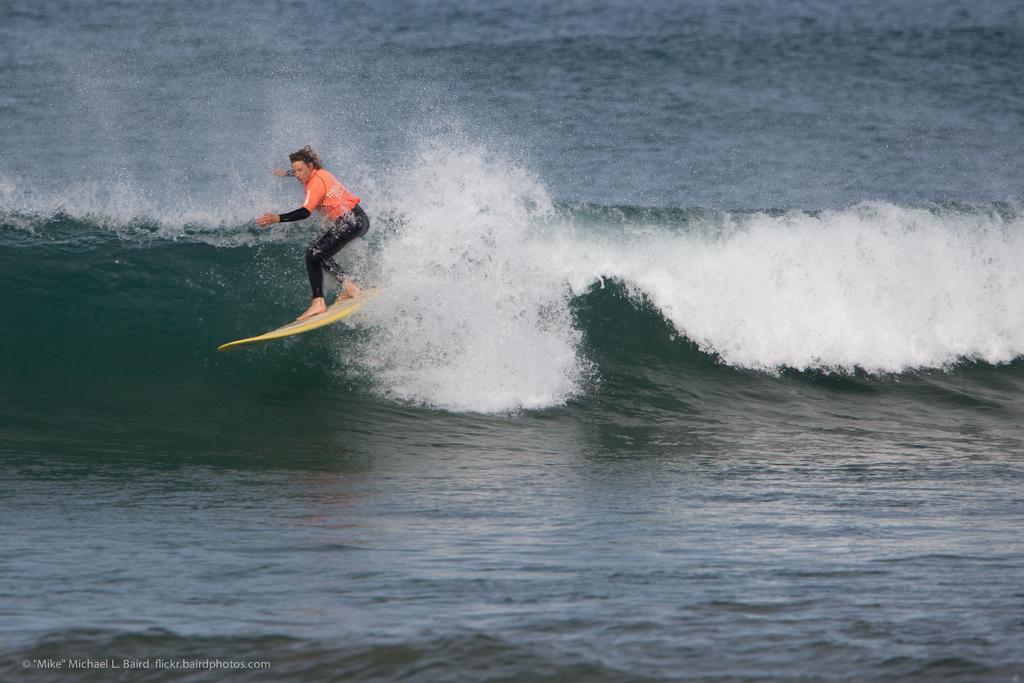How would you summarize this image in a sentence or two? In this image I can see the person with the surfboard. I can see the person is wearing the black and an orange color dress. I can see the person is in the water. 